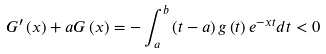<formula> <loc_0><loc_0><loc_500><loc_500>G ^ { \prime } \left ( x \right ) + a G \left ( x \right ) = - \int _ { a } ^ { b } \left ( t - a \right ) g \left ( t \right ) e ^ { - x t } d t < 0</formula> 